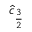<formula> <loc_0><loc_0><loc_500><loc_500>\hat { c } _ { \frac { 3 } { 2 } }</formula> 